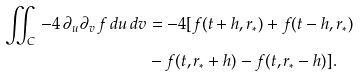Convert formula to latex. <formula><loc_0><loc_0><loc_500><loc_500>\iint _ { C } \, - 4 \, \partial _ { u } \partial _ { v } \, f \, d u \, d v & = - 4 [ f ( t + h , r _ { * } ) + f ( t - h , r _ { * } ) \\ & - f ( t , r _ { * } + h ) - f ( t , r _ { * } - h ) ] .</formula> 